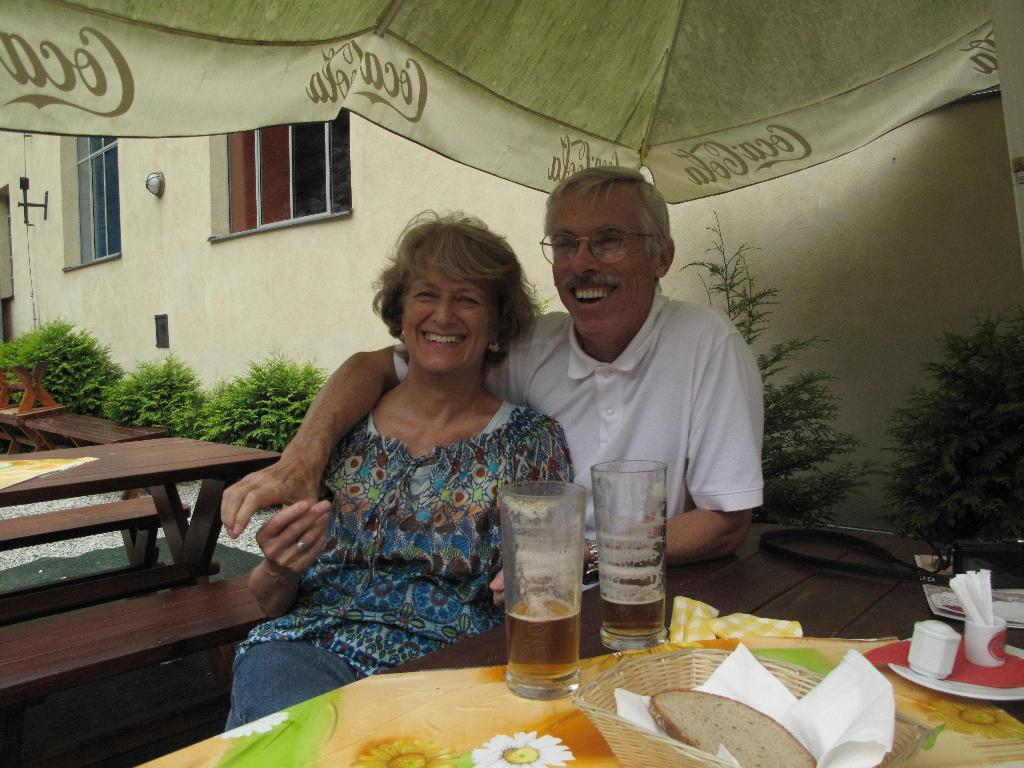How many people are sitting on the bench in the image? There are two people sitting on a bench in the image. What objects can be seen on the table? There are glasses, food, a tissue, and a bowl on the table. What is the background of the image? There is a building at the back side of the image. What type of toy can be seen in the image? There is no toy present in the image. How much honey is on the table in the image? There is no honey present in the image. 